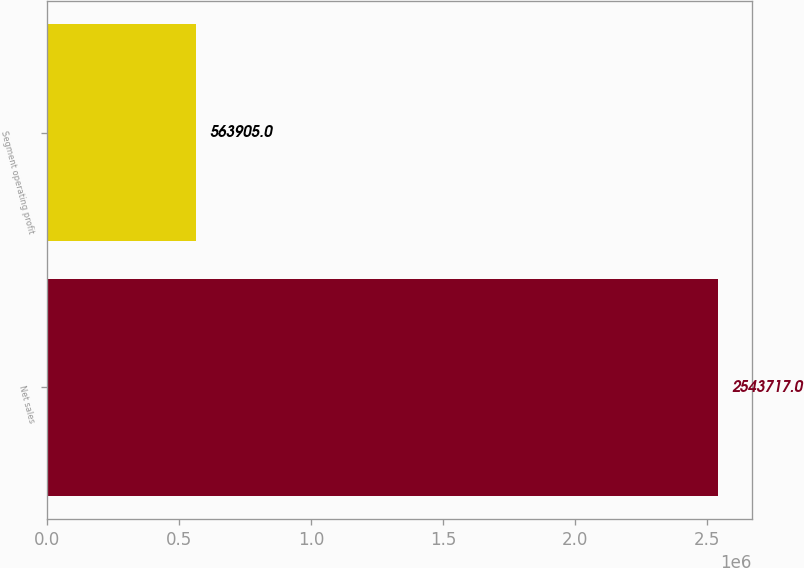Convert chart. <chart><loc_0><loc_0><loc_500><loc_500><bar_chart><fcel>Net sales<fcel>Segment operating profit<nl><fcel>2.54372e+06<fcel>563905<nl></chart> 